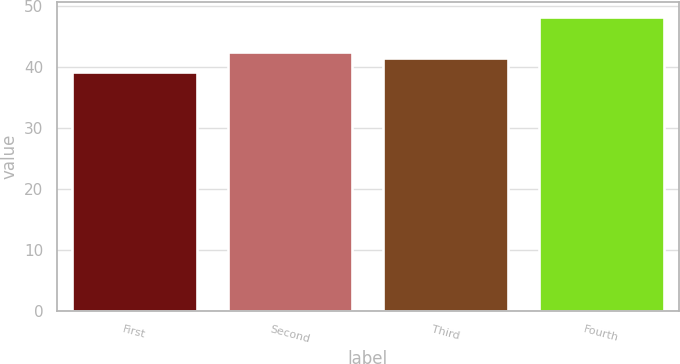Convert chart to OTSL. <chart><loc_0><loc_0><loc_500><loc_500><bar_chart><fcel>First<fcel>Second<fcel>Third<fcel>Fourth<nl><fcel>39.28<fcel>42.49<fcel>41.59<fcel>48.31<nl></chart> 